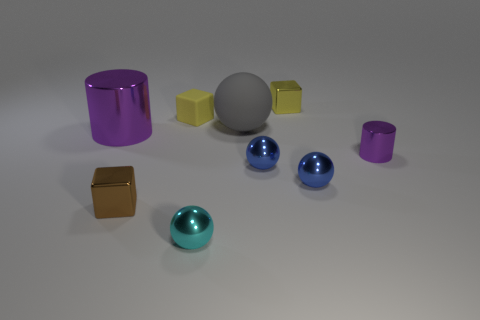Do the cyan object and the tiny yellow matte thing have the same shape?
Provide a short and direct response. No. Is there a small matte thing that has the same shape as the yellow metal object?
Provide a short and direct response. Yes. There is a brown shiny thing that is the same size as the cyan shiny thing; what is its shape?
Offer a very short reply. Cube. The purple cylinder in front of the purple cylinder to the left of the purple cylinder that is to the right of the tiny cyan sphere is made of what material?
Make the answer very short. Metal. Do the gray object and the yellow metallic block have the same size?
Provide a succinct answer. No. What material is the small brown cube?
Offer a very short reply. Metal. There is a thing that is the same color as the tiny cylinder; what material is it?
Keep it short and to the point. Metal. There is a purple thing that is to the left of the yellow shiny object; is it the same shape as the brown thing?
Offer a terse response. No. How many things are either tiny cyan metallic things or tiny purple objects?
Make the answer very short. 2. Is the blue sphere that is left of the yellow metallic block made of the same material as the small brown cube?
Your answer should be very brief. Yes. 